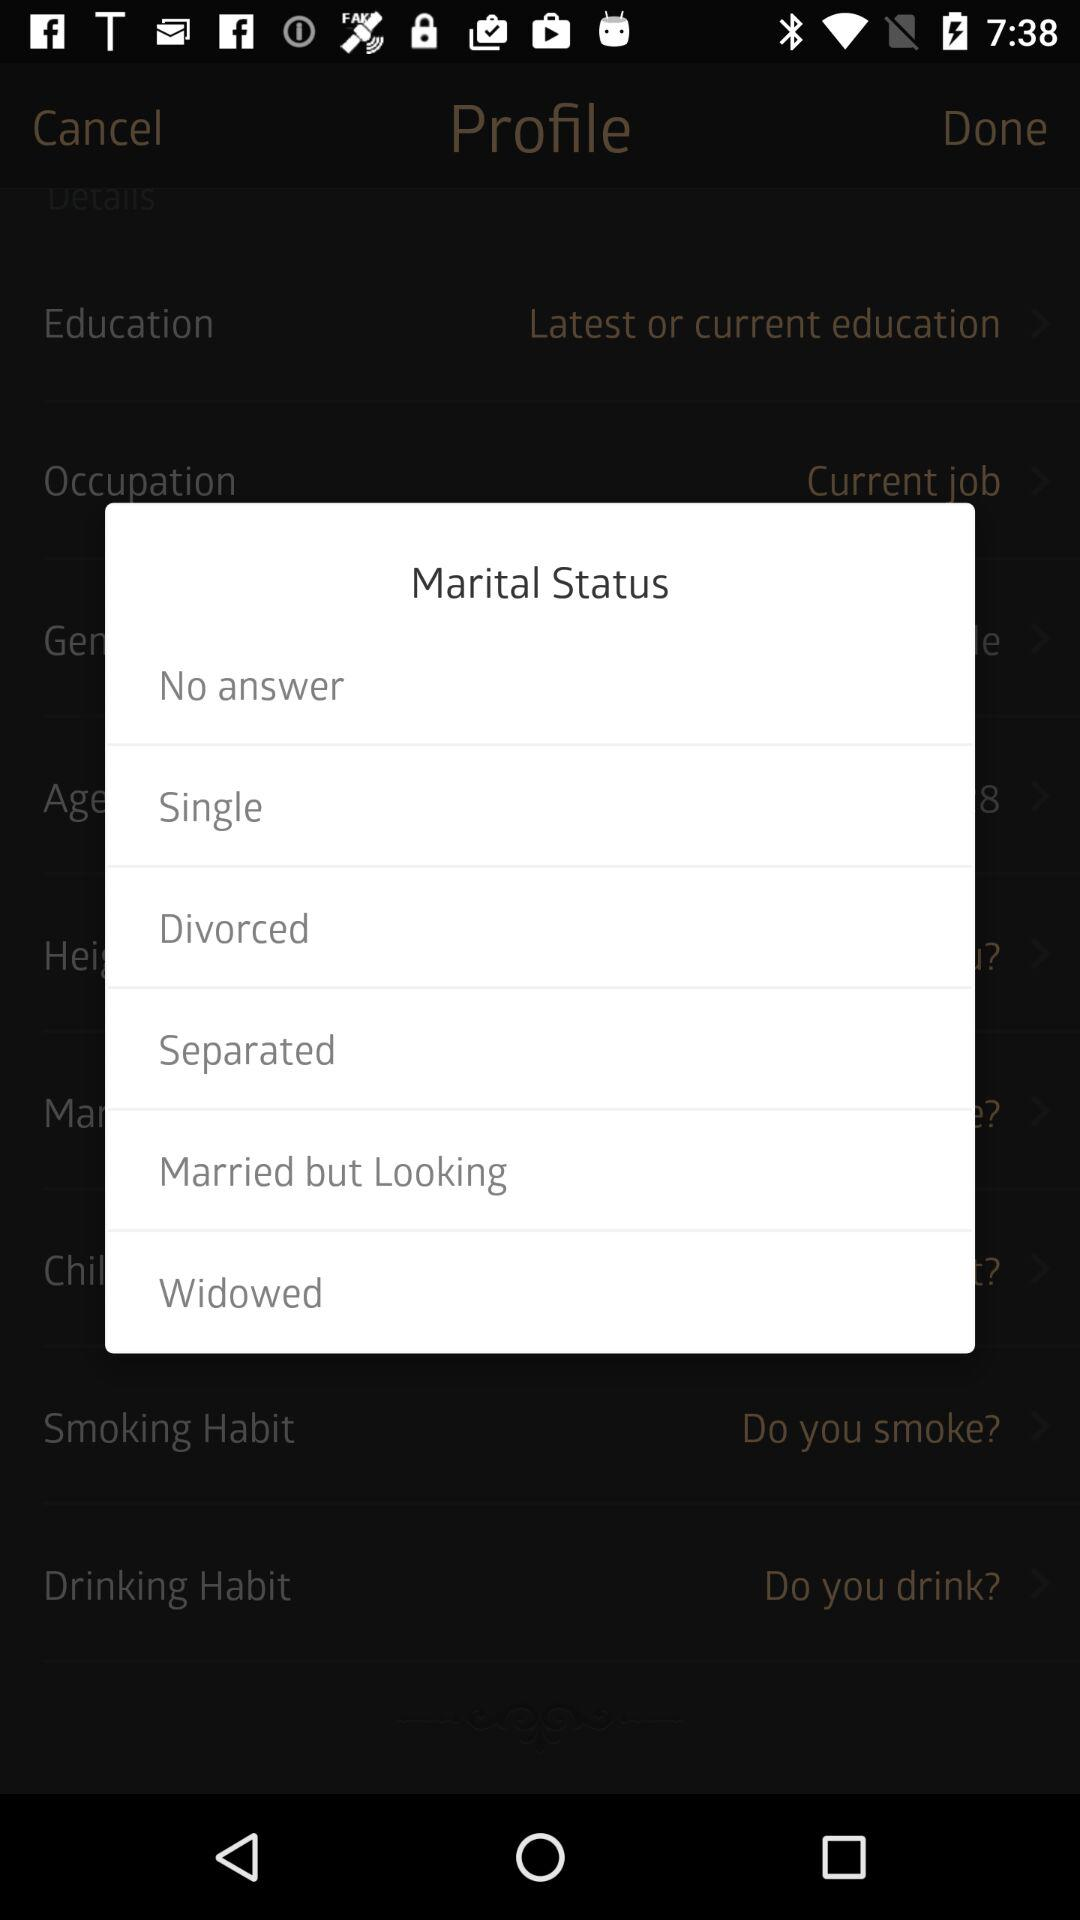How many marital status options are available?
Answer the question using a single word or phrase. 6 